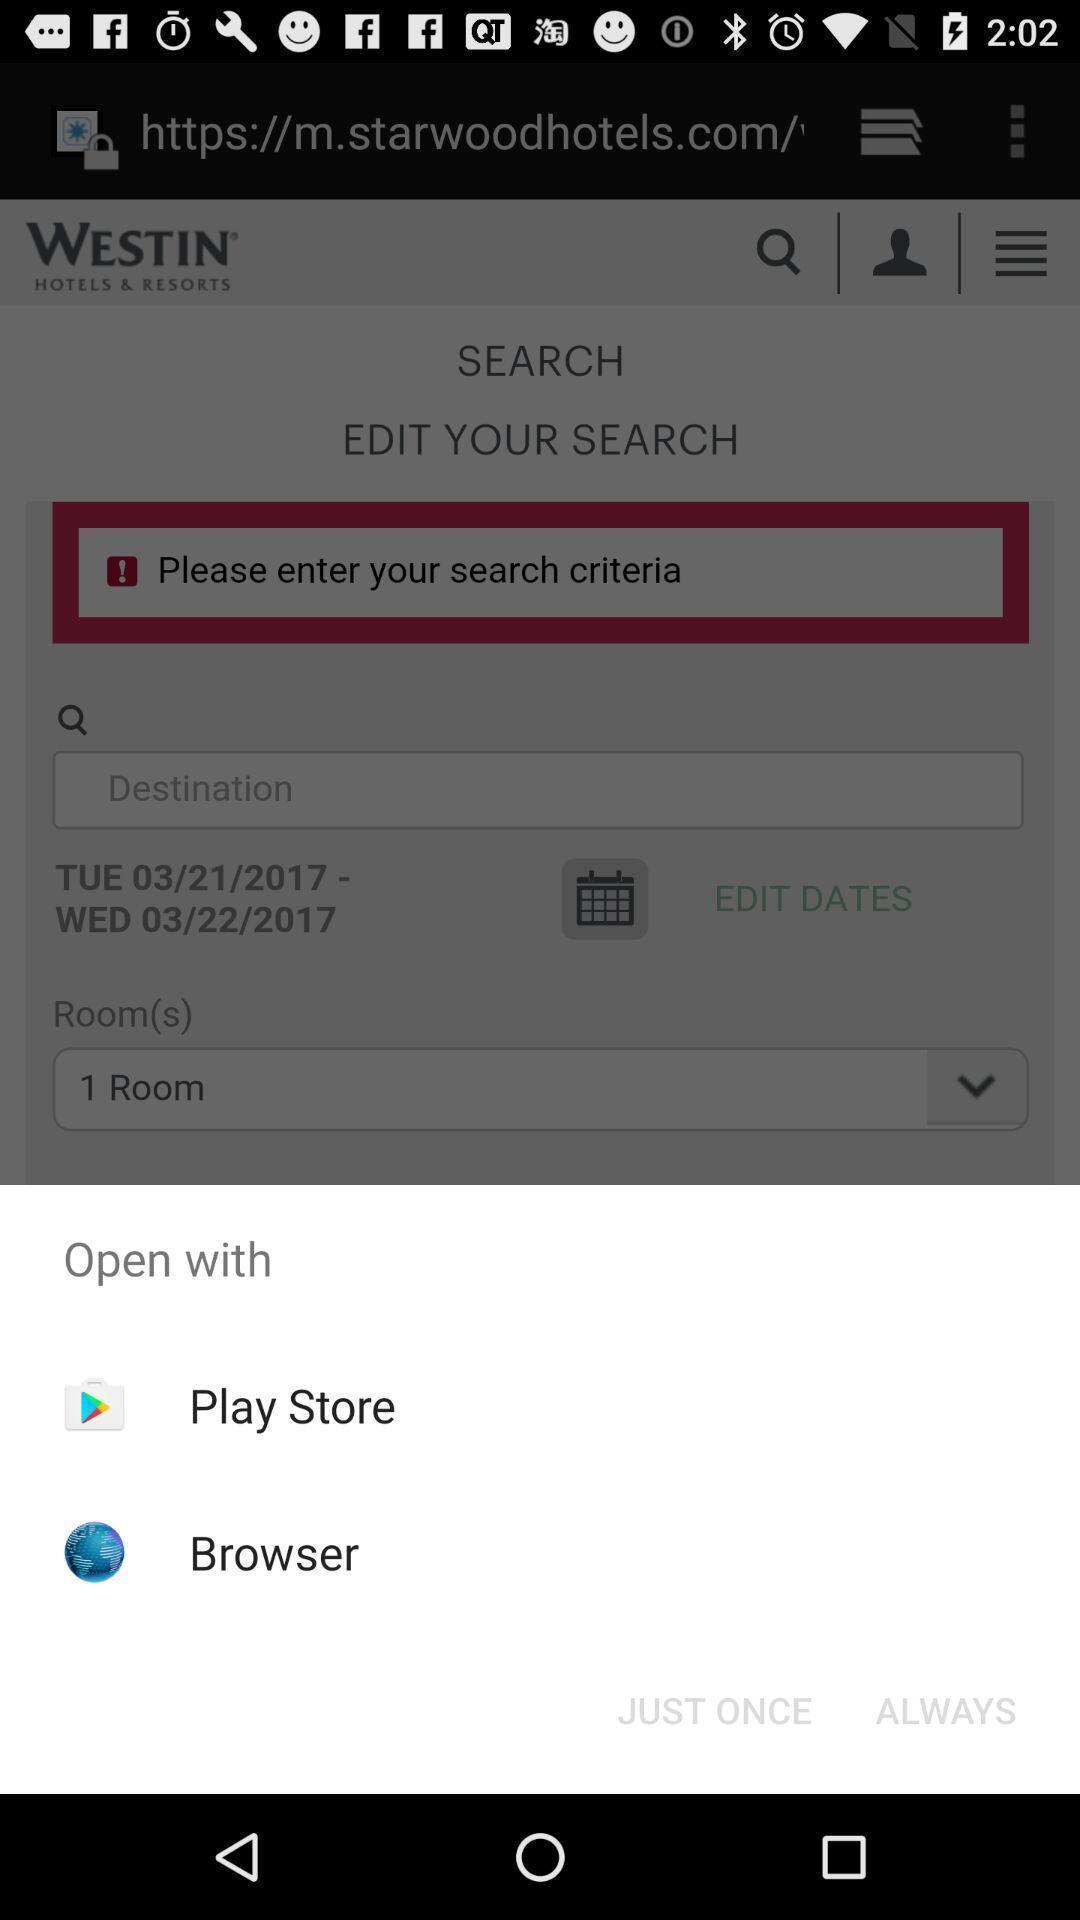Provide a textual representation of this image. Pop-up displaying to open the page. 